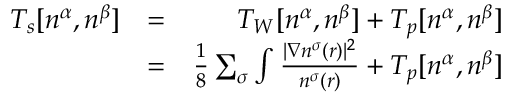Convert formula to latex. <formula><loc_0><loc_0><loc_500><loc_500>\begin{array} { r l r } { T _ { s } [ n ^ { \alpha } , n ^ { \beta } ] } & { = } & { T _ { W } [ n ^ { \alpha } , n ^ { \beta } ] + T _ { p } [ n ^ { \alpha } , n ^ { \beta } ] } \\ & { = } & { \frac { 1 } { 8 } \sum _ { \sigma } \int \frac { | \nabla n ^ { \sigma } ( r ) | ^ { 2 } } { n ^ { \sigma } ( r ) } + T _ { p } [ n ^ { \alpha } , n ^ { \beta } ] } \end{array}</formula> 